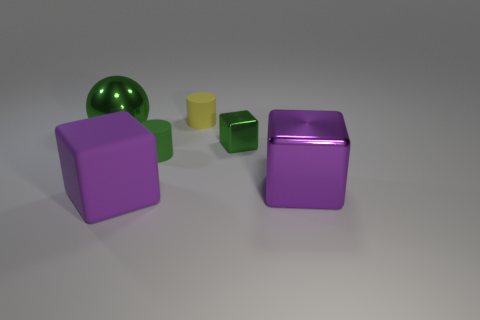What size is the metal object that is the same color as the metal sphere?
Ensure brevity in your answer.  Small. How many cylinders are matte objects or big metal things?
Your answer should be very brief. 2. Does the tiny rubber object behind the large green shiny sphere have the same shape as the purple metal object?
Offer a terse response. No. Is the number of rubber objects behind the large matte object greater than the number of gray matte balls?
Provide a short and direct response. Yes. What is the color of the block that is the same size as the purple shiny thing?
Offer a very short reply. Purple. How many things are either big green metallic things behind the large purple shiny object or small yellow rubber blocks?
Provide a succinct answer. 1. What shape is the shiny object that is the same color as the matte cube?
Make the answer very short. Cube. The purple block right of the purple rubber thing on the right side of the big green sphere is made of what material?
Keep it short and to the point. Metal. Is there another cube that has the same material as the tiny green cube?
Your response must be concise. Yes. Is there a green rubber cylinder that is in front of the large metal thing right of the large green object?
Your answer should be compact. No. 